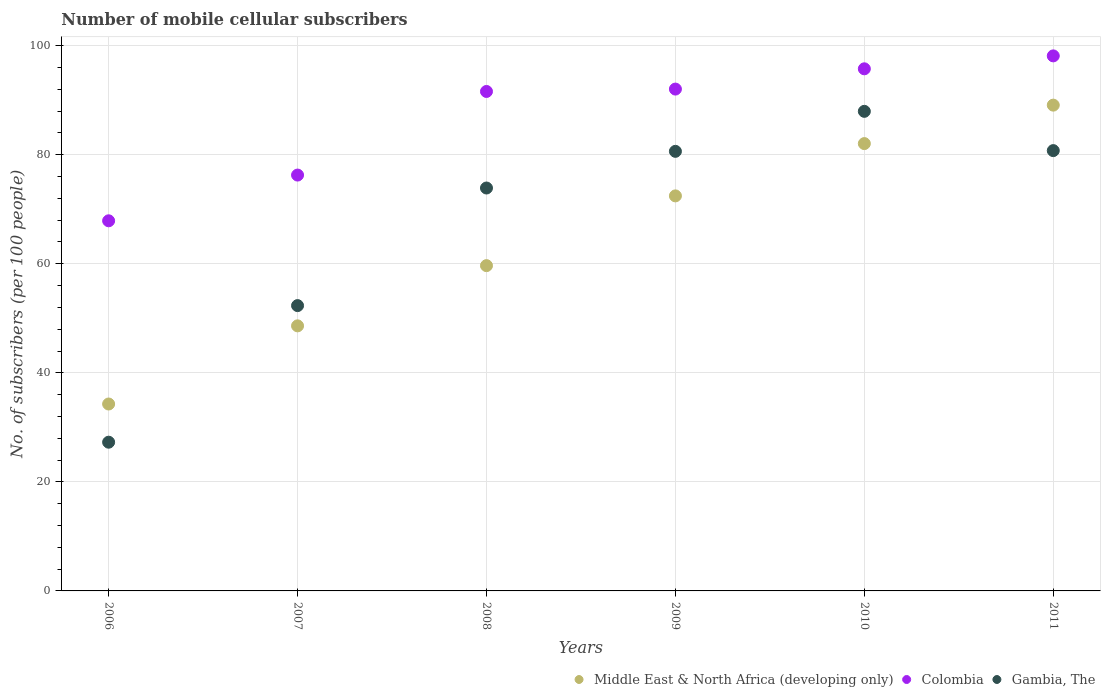Is the number of dotlines equal to the number of legend labels?
Provide a short and direct response. Yes. What is the number of mobile cellular subscribers in Colombia in 2009?
Your response must be concise. 92.05. Across all years, what is the maximum number of mobile cellular subscribers in Gambia, The?
Your answer should be compact. 87.96. Across all years, what is the minimum number of mobile cellular subscribers in Middle East & North Africa (developing only)?
Give a very brief answer. 34.28. In which year was the number of mobile cellular subscribers in Middle East & North Africa (developing only) maximum?
Offer a very short reply. 2011. What is the total number of mobile cellular subscribers in Middle East & North Africa (developing only) in the graph?
Give a very brief answer. 386.17. What is the difference between the number of mobile cellular subscribers in Gambia, The in 2007 and that in 2011?
Offer a terse response. -28.43. What is the difference between the number of mobile cellular subscribers in Middle East & North Africa (developing only) in 2007 and the number of mobile cellular subscribers in Gambia, The in 2009?
Offer a very short reply. -32.01. What is the average number of mobile cellular subscribers in Middle East & North Africa (developing only) per year?
Give a very brief answer. 64.36. In the year 2006, what is the difference between the number of mobile cellular subscribers in Gambia, The and number of mobile cellular subscribers in Colombia?
Provide a succinct answer. -40.61. In how many years, is the number of mobile cellular subscribers in Middle East & North Africa (developing only) greater than 92?
Provide a succinct answer. 0. What is the ratio of the number of mobile cellular subscribers in Colombia in 2006 to that in 2010?
Offer a very short reply. 0.71. Is the number of mobile cellular subscribers in Middle East & North Africa (developing only) in 2007 less than that in 2010?
Your answer should be compact. Yes. What is the difference between the highest and the second highest number of mobile cellular subscribers in Middle East & North Africa (developing only)?
Provide a succinct answer. 7.05. What is the difference between the highest and the lowest number of mobile cellular subscribers in Colombia?
Offer a very short reply. 30.25. In how many years, is the number of mobile cellular subscribers in Middle East & North Africa (developing only) greater than the average number of mobile cellular subscribers in Middle East & North Africa (developing only) taken over all years?
Offer a terse response. 3. Is the number of mobile cellular subscribers in Gambia, The strictly greater than the number of mobile cellular subscribers in Middle East & North Africa (developing only) over the years?
Give a very brief answer. No. Is the number of mobile cellular subscribers in Middle East & North Africa (developing only) strictly less than the number of mobile cellular subscribers in Colombia over the years?
Ensure brevity in your answer.  Yes. How many dotlines are there?
Ensure brevity in your answer.  3. How many years are there in the graph?
Keep it short and to the point. 6. Are the values on the major ticks of Y-axis written in scientific E-notation?
Offer a terse response. No. Does the graph contain grids?
Your response must be concise. Yes. Where does the legend appear in the graph?
Your response must be concise. Bottom right. How many legend labels are there?
Your answer should be very brief. 3. What is the title of the graph?
Make the answer very short. Number of mobile cellular subscribers. Does "Bangladesh" appear as one of the legend labels in the graph?
Provide a succinct answer. No. What is the label or title of the X-axis?
Your answer should be very brief. Years. What is the label or title of the Y-axis?
Your response must be concise. No. of subscribers (per 100 people). What is the No. of subscribers (per 100 people) in Middle East & North Africa (developing only) in 2006?
Ensure brevity in your answer.  34.28. What is the No. of subscribers (per 100 people) of Colombia in 2006?
Give a very brief answer. 67.89. What is the No. of subscribers (per 100 people) in Gambia, The in 2006?
Offer a terse response. 27.28. What is the No. of subscribers (per 100 people) in Middle East & North Africa (developing only) in 2007?
Give a very brief answer. 48.62. What is the No. of subscribers (per 100 people) in Colombia in 2007?
Provide a succinct answer. 76.27. What is the No. of subscribers (per 100 people) of Gambia, The in 2007?
Ensure brevity in your answer.  52.33. What is the No. of subscribers (per 100 people) of Middle East & North Africa (developing only) in 2008?
Keep it short and to the point. 59.66. What is the No. of subscribers (per 100 people) of Colombia in 2008?
Your answer should be compact. 91.61. What is the No. of subscribers (per 100 people) of Gambia, The in 2008?
Your response must be concise. 73.9. What is the No. of subscribers (per 100 people) of Middle East & North Africa (developing only) in 2009?
Provide a short and direct response. 72.46. What is the No. of subscribers (per 100 people) of Colombia in 2009?
Your answer should be compact. 92.05. What is the No. of subscribers (per 100 people) of Gambia, The in 2009?
Offer a very short reply. 80.63. What is the No. of subscribers (per 100 people) in Middle East & North Africa (developing only) in 2010?
Provide a short and direct response. 82.05. What is the No. of subscribers (per 100 people) in Colombia in 2010?
Keep it short and to the point. 95.76. What is the No. of subscribers (per 100 people) of Gambia, The in 2010?
Provide a succinct answer. 87.96. What is the No. of subscribers (per 100 people) in Middle East & North Africa (developing only) in 2011?
Your response must be concise. 89.1. What is the No. of subscribers (per 100 people) of Colombia in 2011?
Provide a short and direct response. 98.13. What is the No. of subscribers (per 100 people) of Gambia, The in 2011?
Your answer should be compact. 80.76. Across all years, what is the maximum No. of subscribers (per 100 people) in Middle East & North Africa (developing only)?
Make the answer very short. 89.1. Across all years, what is the maximum No. of subscribers (per 100 people) of Colombia?
Ensure brevity in your answer.  98.13. Across all years, what is the maximum No. of subscribers (per 100 people) in Gambia, The?
Offer a terse response. 87.96. Across all years, what is the minimum No. of subscribers (per 100 people) in Middle East & North Africa (developing only)?
Make the answer very short. 34.28. Across all years, what is the minimum No. of subscribers (per 100 people) in Colombia?
Provide a succinct answer. 67.89. Across all years, what is the minimum No. of subscribers (per 100 people) in Gambia, The?
Ensure brevity in your answer.  27.28. What is the total No. of subscribers (per 100 people) in Middle East & North Africa (developing only) in the graph?
Your answer should be compact. 386.17. What is the total No. of subscribers (per 100 people) of Colombia in the graph?
Provide a succinct answer. 521.72. What is the total No. of subscribers (per 100 people) in Gambia, The in the graph?
Keep it short and to the point. 402.86. What is the difference between the No. of subscribers (per 100 people) of Middle East & North Africa (developing only) in 2006 and that in 2007?
Offer a very short reply. -14.34. What is the difference between the No. of subscribers (per 100 people) of Colombia in 2006 and that in 2007?
Your answer should be compact. -8.39. What is the difference between the No. of subscribers (per 100 people) of Gambia, The in 2006 and that in 2007?
Provide a short and direct response. -25.05. What is the difference between the No. of subscribers (per 100 people) in Middle East & North Africa (developing only) in 2006 and that in 2008?
Provide a short and direct response. -25.38. What is the difference between the No. of subscribers (per 100 people) of Colombia in 2006 and that in 2008?
Offer a terse response. -23.72. What is the difference between the No. of subscribers (per 100 people) in Gambia, The in 2006 and that in 2008?
Give a very brief answer. -46.62. What is the difference between the No. of subscribers (per 100 people) in Middle East & North Africa (developing only) in 2006 and that in 2009?
Ensure brevity in your answer.  -38.17. What is the difference between the No. of subscribers (per 100 people) of Colombia in 2006 and that in 2009?
Provide a short and direct response. -24.16. What is the difference between the No. of subscribers (per 100 people) in Gambia, The in 2006 and that in 2009?
Provide a succinct answer. -53.35. What is the difference between the No. of subscribers (per 100 people) of Middle East & North Africa (developing only) in 2006 and that in 2010?
Offer a terse response. -47.76. What is the difference between the No. of subscribers (per 100 people) of Colombia in 2006 and that in 2010?
Provide a succinct answer. -27.88. What is the difference between the No. of subscribers (per 100 people) of Gambia, The in 2006 and that in 2010?
Give a very brief answer. -60.69. What is the difference between the No. of subscribers (per 100 people) of Middle East & North Africa (developing only) in 2006 and that in 2011?
Provide a short and direct response. -54.82. What is the difference between the No. of subscribers (per 100 people) in Colombia in 2006 and that in 2011?
Make the answer very short. -30.25. What is the difference between the No. of subscribers (per 100 people) of Gambia, The in 2006 and that in 2011?
Ensure brevity in your answer.  -53.48. What is the difference between the No. of subscribers (per 100 people) in Middle East & North Africa (developing only) in 2007 and that in 2008?
Make the answer very short. -11.04. What is the difference between the No. of subscribers (per 100 people) of Colombia in 2007 and that in 2008?
Provide a succinct answer. -15.34. What is the difference between the No. of subscribers (per 100 people) in Gambia, The in 2007 and that in 2008?
Give a very brief answer. -21.57. What is the difference between the No. of subscribers (per 100 people) in Middle East & North Africa (developing only) in 2007 and that in 2009?
Your response must be concise. -23.84. What is the difference between the No. of subscribers (per 100 people) in Colombia in 2007 and that in 2009?
Give a very brief answer. -15.77. What is the difference between the No. of subscribers (per 100 people) of Gambia, The in 2007 and that in 2009?
Your answer should be compact. -28.29. What is the difference between the No. of subscribers (per 100 people) of Middle East & North Africa (developing only) in 2007 and that in 2010?
Offer a very short reply. -33.43. What is the difference between the No. of subscribers (per 100 people) in Colombia in 2007 and that in 2010?
Ensure brevity in your answer.  -19.49. What is the difference between the No. of subscribers (per 100 people) of Gambia, The in 2007 and that in 2010?
Your answer should be very brief. -35.63. What is the difference between the No. of subscribers (per 100 people) in Middle East & North Africa (developing only) in 2007 and that in 2011?
Keep it short and to the point. -40.48. What is the difference between the No. of subscribers (per 100 people) of Colombia in 2007 and that in 2011?
Your answer should be compact. -21.86. What is the difference between the No. of subscribers (per 100 people) in Gambia, The in 2007 and that in 2011?
Provide a succinct answer. -28.43. What is the difference between the No. of subscribers (per 100 people) in Middle East & North Africa (developing only) in 2008 and that in 2009?
Provide a short and direct response. -12.79. What is the difference between the No. of subscribers (per 100 people) of Colombia in 2008 and that in 2009?
Provide a short and direct response. -0.44. What is the difference between the No. of subscribers (per 100 people) in Gambia, The in 2008 and that in 2009?
Your answer should be compact. -6.73. What is the difference between the No. of subscribers (per 100 people) in Middle East & North Africa (developing only) in 2008 and that in 2010?
Offer a terse response. -22.39. What is the difference between the No. of subscribers (per 100 people) of Colombia in 2008 and that in 2010?
Your answer should be compact. -4.15. What is the difference between the No. of subscribers (per 100 people) of Gambia, The in 2008 and that in 2010?
Make the answer very short. -14.06. What is the difference between the No. of subscribers (per 100 people) in Middle East & North Africa (developing only) in 2008 and that in 2011?
Keep it short and to the point. -29.44. What is the difference between the No. of subscribers (per 100 people) of Colombia in 2008 and that in 2011?
Your response must be concise. -6.52. What is the difference between the No. of subscribers (per 100 people) of Gambia, The in 2008 and that in 2011?
Make the answer very short. -6.86. What is the difference between the No. of subscribers (per 100 people) in Middle East & North Africa (developing only) in 2009 and that in 2010?
Your response must be concise. -9.59. What is the difference between the No. of subscribers (per 100 people) in Colombia in 2009 and that in 2010?
Your answer should be compact. -3.72. What is the difference between the No. of subscribers (per 100 people) in Gambia, The in 2009 and that in 2010?
Ensure brevity in your answer.  -7.34. What is the difference between the No. of subscribers (per 100 people) in Middle East & North Africa (developing only) in 2009 and that in 2011?
Your response must be concise. -16.65. What is the difference between the No. of subscribers (per 100 people) of Colombia in 2009 and that in 2011?
Provide a short and direct response. -6.09. What is the difference between the No. of subscribers (per 100 people) of Gambia, The in 2009 and that in 2011?
Your answer should be compact. -0.13. What is the difference between the No. of subscribers (per 100 people) in Middle East & North Africa (developing only) in 2010 and that in 2011?
Give a very brief answer. -7.05. What is the difference between the No. of subscribers (per 100 people) of Colombia in 2010 and that in 2011?
Provide a short and direct response. -2.37. What is the difference between the No. of subscribers (per 100 people) of Gambia, The in 2010 and that in 2011?
Offer a terse response. 7.2. What is the difference between the No. of subscribers (per 100 people) of Middle East & North Africa (developing only) in 2006 and the No. of subscribers (per 100 people) of Colombia in 2007?
Provide a succinct answer. -41.99. What is the difference between the No. of subscribers (per 100 people) in Middle East & North Africa (developing only) in 2006 and the No. of subscribers (per 100 people) in Gambia, The in 2007?
Offer a terse response. -18.05. What is the difference between the No. of subscribers (per 100 people) of Colombia in 2006 and the No. of subscribers (per 100 people) of Gambia, The in 2007?
Provide a succinct answer. 15.56. What is the difference between the No. of subscribers (per 100 people) in Middle East & North Africa (developing only) in 2006 and the No. of subscribers (per 100 people) in Colombia in 2008?
Your answer should be compact. -57.33. What is the difference between the No. of subscribers (per 100 people) in Middle East & North Africa (developing only) in 2006 and the No. of subscribers (per 100 people) in Gambia, The in 2008?
Offer a very short reply. -39.62. What is the difference between the No. of subscribers (per 100 people) in Colombia in 2006 and the No. of subscribers (per 100 people) in Gambia, The in 2008?
Offer a very short reply. -6.01. What is the difference between the No. of subscribers (per 100 people) in Middle East & North Africa (developing only) in 2006 and the No. of subscribers (per 100 people) in Colombia in 2009?
Your response must be concise. -57.76. What is the difference between the No. of subscribers (per 100 people) of Middle East & North Africa (developing only) in 2006 and the No. of subscribers (per 100 people) of Gambia, The in 2009?
Provide a short and direct response. -46.34. What is the difference between the No. of subscribers (per 100 people) in Colombia in 2006 and the No. of subscribers (per 100 people) in Gambia, The in 2009?
Offer a very short reply. -12.74. What is the difference between the No. of subscribers (per 100 people) in Middle East & North Africa (developing only) in 2006 and the No. of subscribers (per 100 people) in Colombia in 2010?
Make the answer very short. -61.48. What is the difference between the No. of subscribers (per 100 people) of Middle East & North Africa (developing only) in 2006 and the No. of subscribers (per 100 people) of Gambia, The in 2010?
Provide a short and direct response. -53.68. What is the difference between the No. of subscribers (per 100 people) in Colombia in 2006 and the No. of subscribers (per 100 people) in Gambia, The in 2010?
Provide a succinct answer. -20.08. What is the difference between the No. of subscribers (per 100 people) of Middle East & North Africa (developing only) in 2006 and the No. of subscribers (per 100 people) of Colombia in 2011?
Offer a very short reply. -63.85. What is the difference between the No. of subscribers (per 100 people) in Middle East & North Africa (developing only) in 2006 and the No. of subscribers (per 100 people) in Gambia, The in 2011?
Offer a very short reply. -46.48. What is the difference between the No. of subscribers (per 100 people) in Colombia in 2006 and the No. of subscribers (per 100 people) in Gambia, The in 2011?
Offer a very short reply. -12.87. What is the difference between the No. of subscribers (per 100 people) of Middle East & North Africa (developing only) in 2007 and the No. of subscribers (per 100 people) of Colombia in 2008?
Make the answer very short. -42.99. What is the difference between the No. of subscribers (per 100 people) of Middle East & North Africa (developing only) in 2007 and the No. of subscribers (per 100 people) of Gambia, The in 2008?
Your answer should be compact. -25.28. What is the difference between the No. of subscribers (per 100 people) of Colombia in 2007 and the No. of subscribers (per 100 people) of Gambia, The in 2008?
Your answer should be compact. 2.37. What is the difference between the No. of subscribers (per 100 people) in Middle East & North Africa (developing only) in 2007 and the No. of subscribers (per 100 people) in Colombia in 2009?
Keep it short and to the point. -43.43. What is the difference between the No. of subscribers (per 100 people) in Middle East & North Africa (developing only) in 2007 and the No. of subscribers (per 100 people) in Gambia, The in 2009?
Give a very brief answer. -32.01. What is the difference between the No. of subscribers (per 100 people) in Colombia in 2007 and the No. of subscribers (per 100 people) in Gambia, The in 2009?
Ensure brevity in your answer.  -4.35. What is the difference between the No. of subscribers (per 100 people) of Middle East & North Africa (developing only) in 2007 and the No. of subscribers (per 100 people) of Colombia in 2010?
Your answer should be compact. -47.15. What is the difference between the No. of subscribers (per 100 people) of Middle East & North Africa (developing only) in 2007 and the No. of subscribers (per 100 people) of Gambia, The in 2010?
Give a very brief answer. -39.34. What is the difference between the No. of subscribers (per 100 people) of Colombia in 2007 and the No. of subscribers (per 100 people) of Gambia, The in 2010?
Ensure brevity in your answer.  -11.69. What is the difference between the No. of subscribers (per 100 people) in Middle East & North Africa (developing only) in 2007 and the No. of subscribers (per 100 people) in Colombia in 2011?
Your answer should be compact. -49.52. What is the difference between the No. of subscribers (per 100 people) of Middle East & North Africa (developing only) in 2007 and the No. of subscribers (per 100 people) of Gambia, The in 2011?
Keep it short and to the point. -32.14. What is the difference between the No. of subscribers (per 100 people) in Colombia in 2007 and the No. of subscribers (per 100 people) in Gambia, The in 2011?
Your response must be concise. -4.49. What is the difference between the No. of subscribers (per 100 people) in Middle East & North Africa (developing only) in 2008 and the No. of subscribers (per 100 people) in Colombia in 2009?
Offer a terse response. -32.38. What is the difference between the No. of subscribers (per 100 people) of Middle East & North Africa (developing only) in 2008 and the No. of subscribers (per 100 people) of Gambia, The in 2009?
Make the answer very short. -20.96. What is the difference between the No. of subscribers (per 100 people) of Colombia in 2008 and the No. of subscribers (per 100 people) of Gambia, The in 2009?
Provide a short and direct response. 10.98. What is the difference between the No. of subscribers (per 100 people) of Middle East & North Africa (developing only) in 2008 and the No. of subscribers (per 100 people) of Colombia in 2010?
Provide a short and direct response. -36.1. What is the difference between the No. of subscribers (per 100 people) in Middle East & North Africa (developing only) in 2008 and the No. of subscribers (per 100 people) in Gambia, The in 2010?
Your answer should be compact. -28.3. What is the difference between the No. of subscribers (per 100 people) in Colombia in 2008 and the No. of subscribers (per 100 people) in Gambia, The in 2010?
Provide a succinct answer. 3.65. What is the difference between the No. of subscribers (per 100 people) of Middle East & North Africa (developing only) in 2008 and the No. of subscribers (per 100 people) of Colombia in 2011?
Offer a terse response. -38.47. What is the difference between the No. of subscribers (per 100 people) of Middle East & North Africa (developing only) in 2008 and the No. of subscribers (per 100 people) of Gambia, The in 2011?
Provide a short and direct response. -21.1. What is the difference between the No. of subscribers (per 100 people) in Colombia in 2008 and the No. of subscribers (per 100 people) in Gambia, The in 2011?
Keep it short and to the point. 10.85. What is the difference between the No. of subscribers (per 100 people) of Middle East & North Africa (developing only) in 2009 and the No. of subscribers (per 100 people) of Colombia in 2010?
Provide a short and direct response. -23.31. What is the difference between the No. of subscribers (per 100 people) of Middle East & North Africa (developing only) in 2009 and the No. of subscribers (per 100 people) of Gambia, The in 2010?
Your response must be concise. -15.51. What is the difference between the No. of subscribers (per 100 people) in Colombia in 2009 and the No. of subscribers (per 100 people) in Gambia, The in 2010?
Provide a short and direct response. 4.08. What is the difference between the No. of subscribers (per 100 people) of Middle East & North Africa (developing only) in 2009 and the No. of subscribers (per 100 people) of Colombia in 2011?
Provide a succinct answer. -25.68. What is the difference between the No. of subscribers (per 100 people) in Middle East & North Africa (developing only) in 2009 and the No. of subscribers (per 100 people) in Gambia, The in 2011?
Provide a short and direct response. -8.3. What is the difference between the No. of subscribers (per 100 people) of Colombia in 2009 and the No. of subscribers (per 100 people) of Gambia, The in 2011?
Your answer should be very brief. 11.29. What is the difference between the No. of subscribers (per 100 people) of Middle East & North Africa (developing only) in 2010 and the No. of subscribers (per 100 people) of Colombia in 2011?
Make the answer very short. -16.09. What is the difference between the No. of subscribers (per 100 people) of Middle East & North Africa (developing only) in 2010 and the No. of subscribers (per 100 people) of Gambia, The in 2011?
Provide a succinct answer. 1.29. What is the difference between the No. of subscribers (per 100 people) in Colombia in 2010 and the No. of subscribers (per 100 people) in Gambia, The in 2011?
Give a very brief answer. 15. What is the average No. of subscribers (per 100 people) of Middle East & North Africa (developing only) per year?
Keep it short and to the point. 64.36. What is the average No. of subscribers (per 100 people) in Colombia per year?
Give a very brief answer. 86.95. What is the average No. of subscribers (per 100 people) of Gambia, The per year?
Give a very brief answer. 67.14. In the year 2006, what is the difference between the No. of subscribers (per 100 people) in Middle East & North Africa (developing only) and No. of subscribers (per 100 people) in Colombia?
Keep it short and to the point. -33.6. In the year 2006, what is the difference between the No. of subscribers (per 100 people) in Middle East & North Africa (developing only) and No. of subscribers (per 100 people) in Gambia, The?
Keep it short and to the point. 7.01. In the year 2006, what is the difference between the No. of subscribers (per 100 people) of Colombia and No. of subscribers (per 100 people) of Gambia, The?
Give a very brief answer. 40.61. In the year 2007, what is the difference between the No. of subscribers (per 100 people) of Middle East & North Africa (developing only) and No. of subscribers (per 100 people) of Colombia?
Give a very brief answer. -27.66. In the year 2007, what is the difference between the No. of subscribers (per 100 people) in Middle East & North Africa (developing only) and No. of subscribers (per 100 people) in Gambia, The?
Keep it short and to the point. -3.71. In the year 2007, what is the difference between the No. of subscribers (per 100 people) of Colombia and No. of subscribers (per 100 people) of Gambia, The?
Provide a short and direct response. 23.94. In the year 2008, what is the difference between the No. of subscribers (per 100 people) of Middle East & North Africa (developing only) and No. of subscribers (per 100 people) of Colombia?
Offer a very short reply. -31.95. In the year 2008, what is the difference between the No. of subscribers (per 100 people) in Middle East & North Africa (developing only) and No. of subscribers (per 100 people) in Gambia, The?
Give a very brief answer. -14.24. In the year 2008, what is the difference between the No. of subscribers (per 100 people) of Colombia and No. of subscribers (per 100 people) of Gambia, The?
Make the answer very short. 17.71. In the year 2009, what is the difference between the No. of subscribers (per 100 people) in Middle East & North Africa (developing only) and No. of subscribers (per 100 people) in Colombia?
Offer a very short reply. -19.59. In the year 2009, what is the difference between the No. of subscribers (per 100 people) in Middle East & North Africa (developing only) and No. of subscribers (per 100 people) in Gambia, The?
Give a very brief answer. -8.17. In the year 2009, what is the difference between the No. of subscribers (per 100 people) of Colombia and No. of subscribers (per 100 people) of Gambia, The?
Your answer should be compact. 11.42. In the year 2010, what is the difference between the No. of subscribers (per 100 people) in Middle East & North Africa (developing only) and No. of subscribers (per 100 people) in Colombia?
Offer a very short reply. -13.72. In the year 2010, what is the difference between the No. of subscribers (per 100 people) of Middle East & North Africa (developing only) and No. of subscribers (per 100 people) of Gambia, The?
Your answer should be compact. -5.92. In the year 2010, what is the difference between the No. of subscribers (per 100 people) in Colombia and No. of subscribers (per 100 people) in Gambia, The?
Give a very brief answer. 7.8. In the year 2011, what is the difference between the No. of subscribers (per 100 people) in Middle East & North Africa (developing only) and No. of subscribers (per 100 people) in Colombia?
Offer a very short reply. -9.03. In the year 2011, what is the difference between the No. of subscribers (per 100 people) of Middle East & North Africa (developing only) and No. of subscribers (per 100 people) of Gambia, The?
Provide a succinct answer. 8.34. In the year 2011, what is the difference between the No. of subscribers (per 100 people) in Colombia and No. of subscribers (per 100 people) in Gambia, The?
Your answer should be compact. 17.37. What is the ratio of the No. of subscribers (per 100 people) in Middle East & North Africa (developing only) in 2006 to that in 2007?
Provide a succinct answer. 0.71. What is the ratio of the No. of subscribers (per 100 people) in Colombia in 2006 to that in 2007?
Provide a succinct answer. 0.89. What is the ratio of the No. of subscribers (per 100 people) in Gambia, The in 2006 to that in 2007?
Give a very brief answer. 0.52. What is the ratio of the No. of subscribers (per 100 people) of Middle East & North Africa (developing only) in 2006 to that in 2008?
Make the answer very short. 0.57. What is the ratio of the No. of subscribers (per 100 people) of Colombia in 2006 to that in 2008?
Offer a very short reply. 0.74. What is the ratio of the No. of subscribers (per 100 people) of Gambia, The in 2006 to that in 2008?
Offer a very short reply. 0.37. What is the ratio of the No. of subscribers (per 100 people) in Middle East & North Africa (developing only) in 2006 to that in 2009?
Provide a short and direct response. 0.47. What is the ratio of the No. of subscribers (per 100 people) of Colombia in 2006 to that in 2009?
Give a very brief answer. 0.74. What is the ratio of the No. of subscribers (per 100 people) of Gambia, The in 2006 to that in 2009?
Provide a short and direct response. 0.34. What is the ratio of the No. of subscribers (per 100 people) in Middle East & North Africa (developing only) in 2006 to that in 2010?
Your response must be concise. 0.42. What is the ratio of the No. of subscribers (per 100 people) of Colombia in 2006 to that in 2010?
Your answer should be very brief. 0.71. What is the ratio of the No. of subscribers (per 100 people) of Gambia, The in 2006 to that in 2010?
Your answer should be compact. 0.31. What is the ratio of the No. of subscribers (per 100 people) in Middle East & North Africa (developing only) in 2006 to that in 2011?
Keep it short and to the point. 0.38. What is the ratio of the No. of subscribers (per 100 people) of Colombia in 2006 to that in 2011?
Your response must be concise. 0.69. What is the ratio of the No. of subscribers (per 100 people) in Gambia, The in 2006 to that in 2011?
Your response must be concise. 0.34. What is the ratio of the No. of subscribers (per 100 people) in Middle East & North Africa (developing only) in 2007 to that in 2008?
Provide a short and direct response. 0.81. What is the ratio of the No. of subscribers (per 100 people) in Colombia in 2007 to that in 2008?
Provide a short and direct response. 0.83. What is the ratio of the No. of subscribers (per 100 people) in Gambia, The in 2007 to that in 2008?
Keep it short and to the point. 0.71. What is the ratio of the No. of subscribers (per 100 people) of Middle East & North Africa (developing only) in 2007 to that in 2009?
Make the answer very short. 0.67. What is the ratio of the No. of subscribers (per 100 people) in Colombia in 2007 to that in 2009?
Make the answer very short. 0.83. What is the ratio of the No. of subscribers (per 100 people) in Gambia, The in 2007 to that in 2009?
Ensure brevity in your answer.  0.65. What is the ratio of the No. of subscribers (per 100 people) in Middle East & North Africa (developing only) in 2007 to that in 2010?
Give a very brief answer. 0.59. What is the ratio of the No. of subscribers (per 100 people) of Colombia in 2007 to that in 2010?
Your answer should be compact. 0.8. What is the ratio of the No. of subscribers (per 100 people) of Gambia, The in 2007 to that in 2010?
Your answer should be very brief. 0.59. What is the ratio of the No. of subscribers (per 100 people) in Middle East & North Africa (developing only) in 2007 to that in 2011?
Make the answer very short. 0.55. What is the ratio of the No. of subscribers (per 100 people) in Colombia in 2007 to that in 2011?
Provide a succinct answer. 0.78. What is the ratio of the No. of subscribers (per 100 people) of Gambia, The in 2007 to that in 2011?
Provide a short and direct response. 0.65. What is the ratio of the No. of subscribers (per 100 people) in Middle East & North Africa (developing only) in 2008 to that in 2009?
Keep it short and to the point. 0.82. What is the ratio of the No. of subscribers (per 100 people) of Gambia, The in 2008 to that in 2009?
Provide a succinct answer. 0.92. What is the ratio of the No. of subscribers (per 100 people) in Middle East & North Africa (developing only) in 2008 to that in 2010?
Offer a terse response. 0.73. What is the ratio of the No. of subscribers (per 100 people) in Colombia in 2008 to that in 2010?
Keep it short and to the point. 0.96. What is the ratio of the No. of subscribers (per 100 people) of Gambia, The in 2008 to that in 2010?
Your response must be concise. 0.84. What is the ratio of the No. of subscribers (per 100 people) in Middle East & North Africa (developing only) in 2008 to that in 2011?
Give a very brief answer. 0.67. What is the ratio of the No. of subscribers (per 100 people) in Colombia in 2008 to that in 2011?
Your answer should be very brief. 0.93. What is the ratio of the No. of subscribers (per 100 people) of Gambia, The in 2008 to that in 2011?
Provide a succinct answer. 0.92. What is the ratio of the No. of subscribers (per 100 people) in Middle East & North Africa (developing only) in 2009 to that in 2010?
Your answer should be compact. 0.88. What is the ratio of the No. of subscribers (per 100 people) in Colombia in 2009 to that in 2010?
Your answer should be compact. 0.96. What is the ratio of the No. of subscribers (per 100 people) of Gambia, The in 2009 to that in 2010?
Offer a very short reply. 0.92. What is the ratio of the No. of subscribers (per 100 people) in Middle East & North Africa (developing only) in 2009 to that in 2011?
Offer a very short reply. 0.81. What is the ratio of the No. of subscribers (per 100 people) of Colombia in 2009 to that in 2011?
Your answer should be very brief. 0.94. What is the ratio of the No. of subscribers (per 100 people) of Middle East & North Africa (developing only) in 2010 to that in 2011?
Keep it short and to the point. 0.92. What is the ratio of the No. of subscribers (per 100 people) in Colombia in 2010 to that in 2011?
Make the answer very short. 0.98. What is the ratio of the No. of subscribers (per 100 people) of Gambia, The in 2010 to that in 2011?
Your response must be concise. 1.09. What is the difference between the highest and the second highest No. of subscribers (per 100 people) in Middle East & North Africa (developing only)?
Offer a very short reply. 7.05. What is the difference between the highest and the second highest No. of subscribers (per 100 people) of Colombia?
Your answer should be very brief. 2.37. What is the difference between the highest and the second highest No. of subscribers (per 100 people) of Gambia, The?
Make the answer very short. 7.2. What is the difference between the highest and the lowest No. of subscribers (per 100 people) in Middle East & North Africa (developing only)?
Ensure brevity in your answer.  54.82. What is the difference between the highest and the lowest No. of subscribers (per 100 people) of Colombia?
Provide a succinct answer. 30.25. What is the difference between the highest and the lowest No. of subscribers (per 100 people) in Gambia, The?
Make the answer very short. 60.69. 